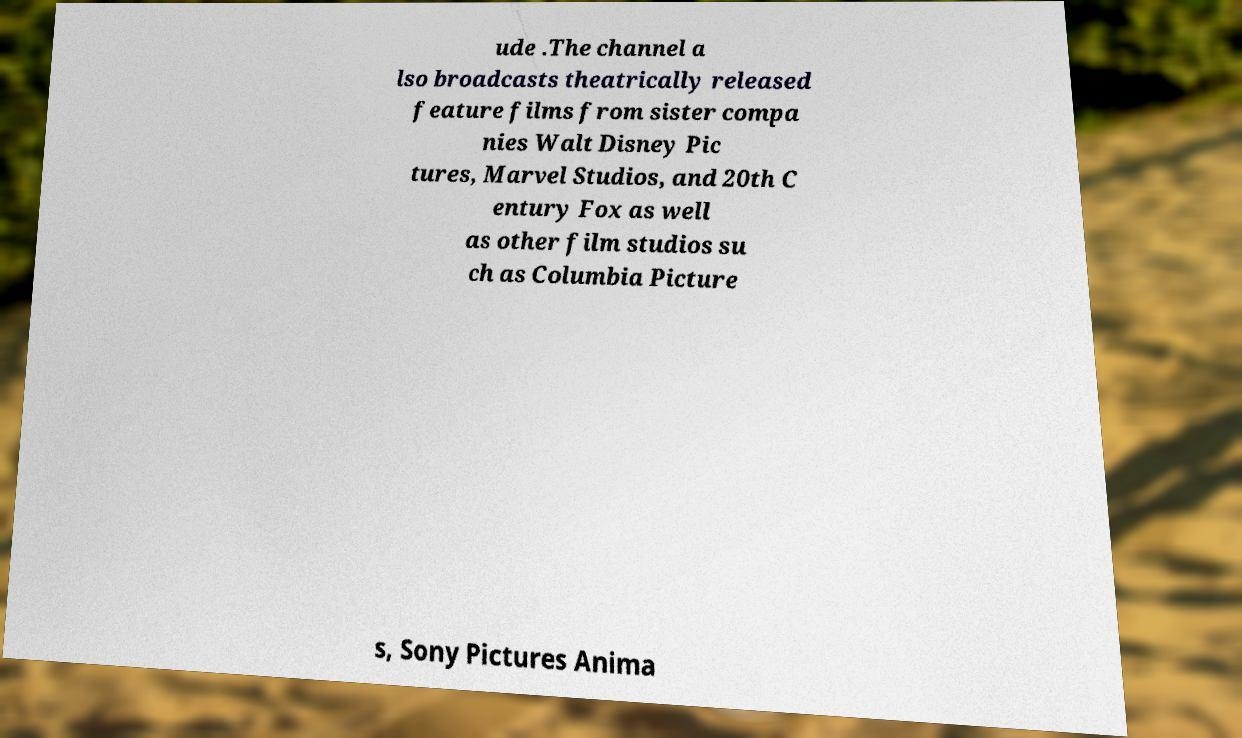Please identify and transcribe the text found in this image. ude .The channel a lso broadcasts theatrically released feature films from sister compa nies Walt Disney Pic tures, Marvel Studios, and 20th C entury Fox as well as other film studios su ch as Columbia Picture s, Sony Pictures Anima 